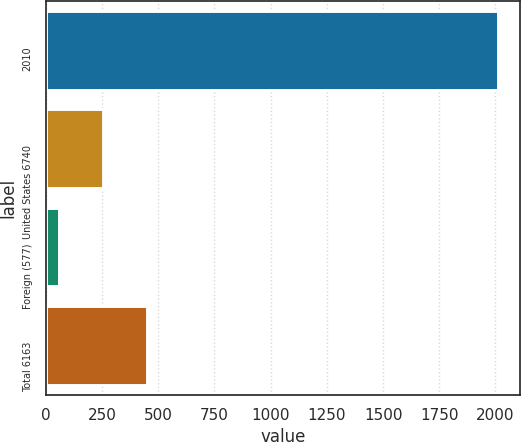Convert chart. <chart><loc_0><loc_0><loc_500><loc_500><bar_chart><fcel>2010<fcel>United States 6740<fcel>Foreign (577)<fcel>Total 6163<nl><fcel>2009<fcel>255.44<fcel>60.6<fcel>450.28<nl></chart> 